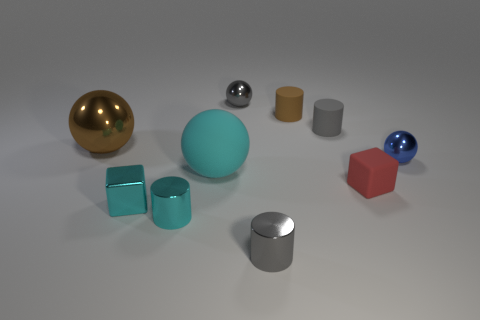The cyan object that is made of the same material as the small red block is what size? The cyan object, sharing the same matte material characteristic as the small red block, is medium-sized in comparison to the other objects in the image. 